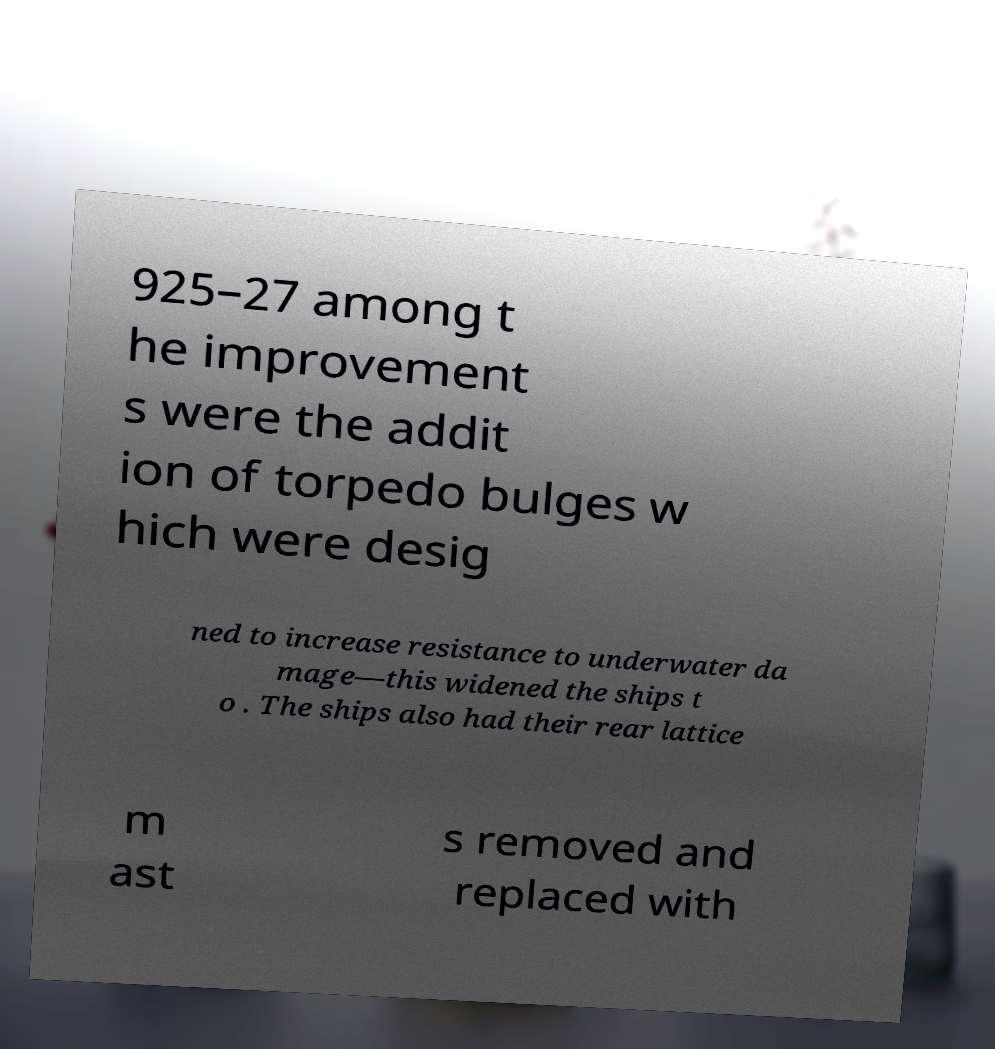Can you read and provide the text displayed in the image?This photo seems to have some interesting text. Can you extract and type it out for me? 925–27 among t he improvement s were the addit ion of torpedo bulges w hich were desig ned to increase resistance to underwater da mage—this widened the ships t o . The ships also had their rear lattice m ast s removed and replaced with 